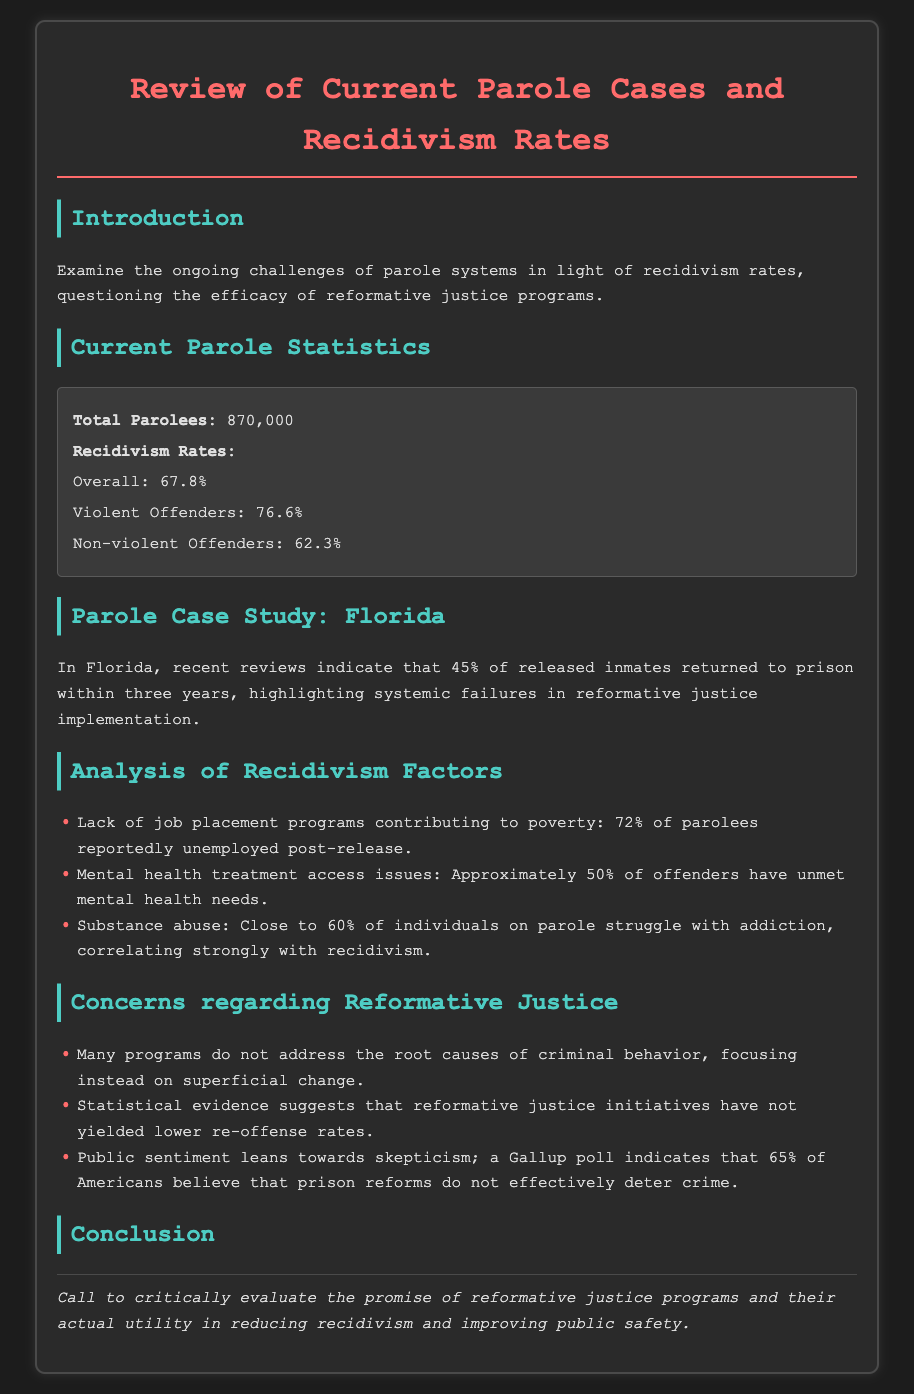What is the total number of parolees? The document specifies that the total number of parolees is 870,000.
Answer: 870,000 What is the overall recidivism rate? According to the statistics provided, the overall recidivism rate is 67.8%.
Answer: 67.8% What percentage of released inmates in Florida return to prison within three years? The document states that 45% of released inmates in Florida returned to prison within three years.
Answer: 45% What is the percentage of parolees that are unemployed post-release? It is noted that 72% of parolees reportedly unemployed after release.
Answer: 72% What proportion of Americans believe prison reforms do not effectively deter crime? A Gallup poll indicates that 65% of Americans hold this belief.
Answer: 65% What percentage of offenders have unmet mental health needs? The document mentions that approximately 50% of offenders have unmet mental health needs.
Answer: 50% What is the recidivism rate for violent offenders? The document specifies that the recidivism rate for violent offenders is 76.6%.
Answer: 76.6% What issue is correlated strongly with recidivism? The document notes that close to 60% of individuals on parole struggle with addiction, correlating strongly with recidivism.
Answer: Addiction What aspect of reformative justice programs is criticized? The document states that many programs focus on superficial change instead of addressing root causes of criminal behavior.
Answer: Superficial change 